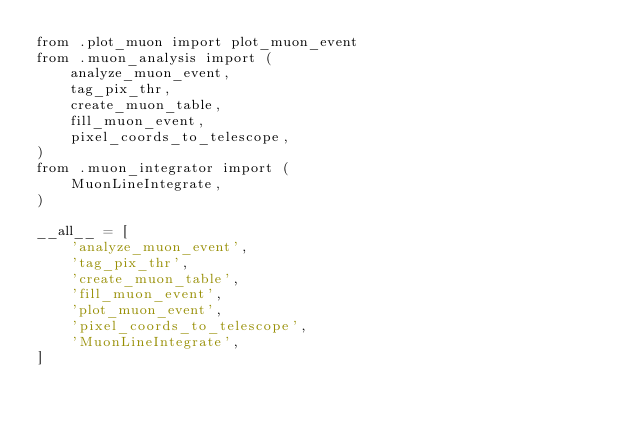Convert code to text. <code><loc_0><loc_0><loc_500><loc_500><_Python_>from .plot_muon import plot_muon_event
from .muon_analysis import (
    analyze_muon_event,
    tag_pix_thr,
    create_muon_table,
    fill_muon_event,
    pixel_coords_to_telescope,
)
from .muon_integrator import (
    MuonLineIntegrate,
)

__all__ = [
    'analyze_muon_event',
    'tag_pix_thr',
    'create_muon_table',
    'fill_muon_event',
    'plot_muon_event',
    'pixel_coords_to_telescope',
    'MuonLineIntegrate',
]
</code> 